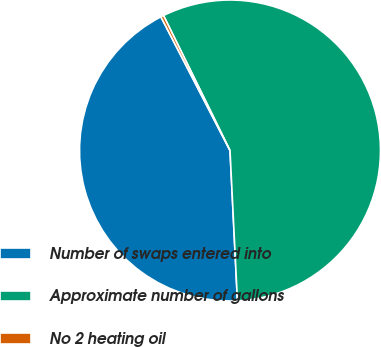Convert chart to OTSL. <chart><loc_0><loc_0><loc_500><loc_500><pie_chart><fcel>Number of swaps entered into<fcel>Approximate number of gallons<fcel>No 2 heating oil<nl><fcel>43.19%<fcel>56.5%<fcel>0.31%<nl></chart> 